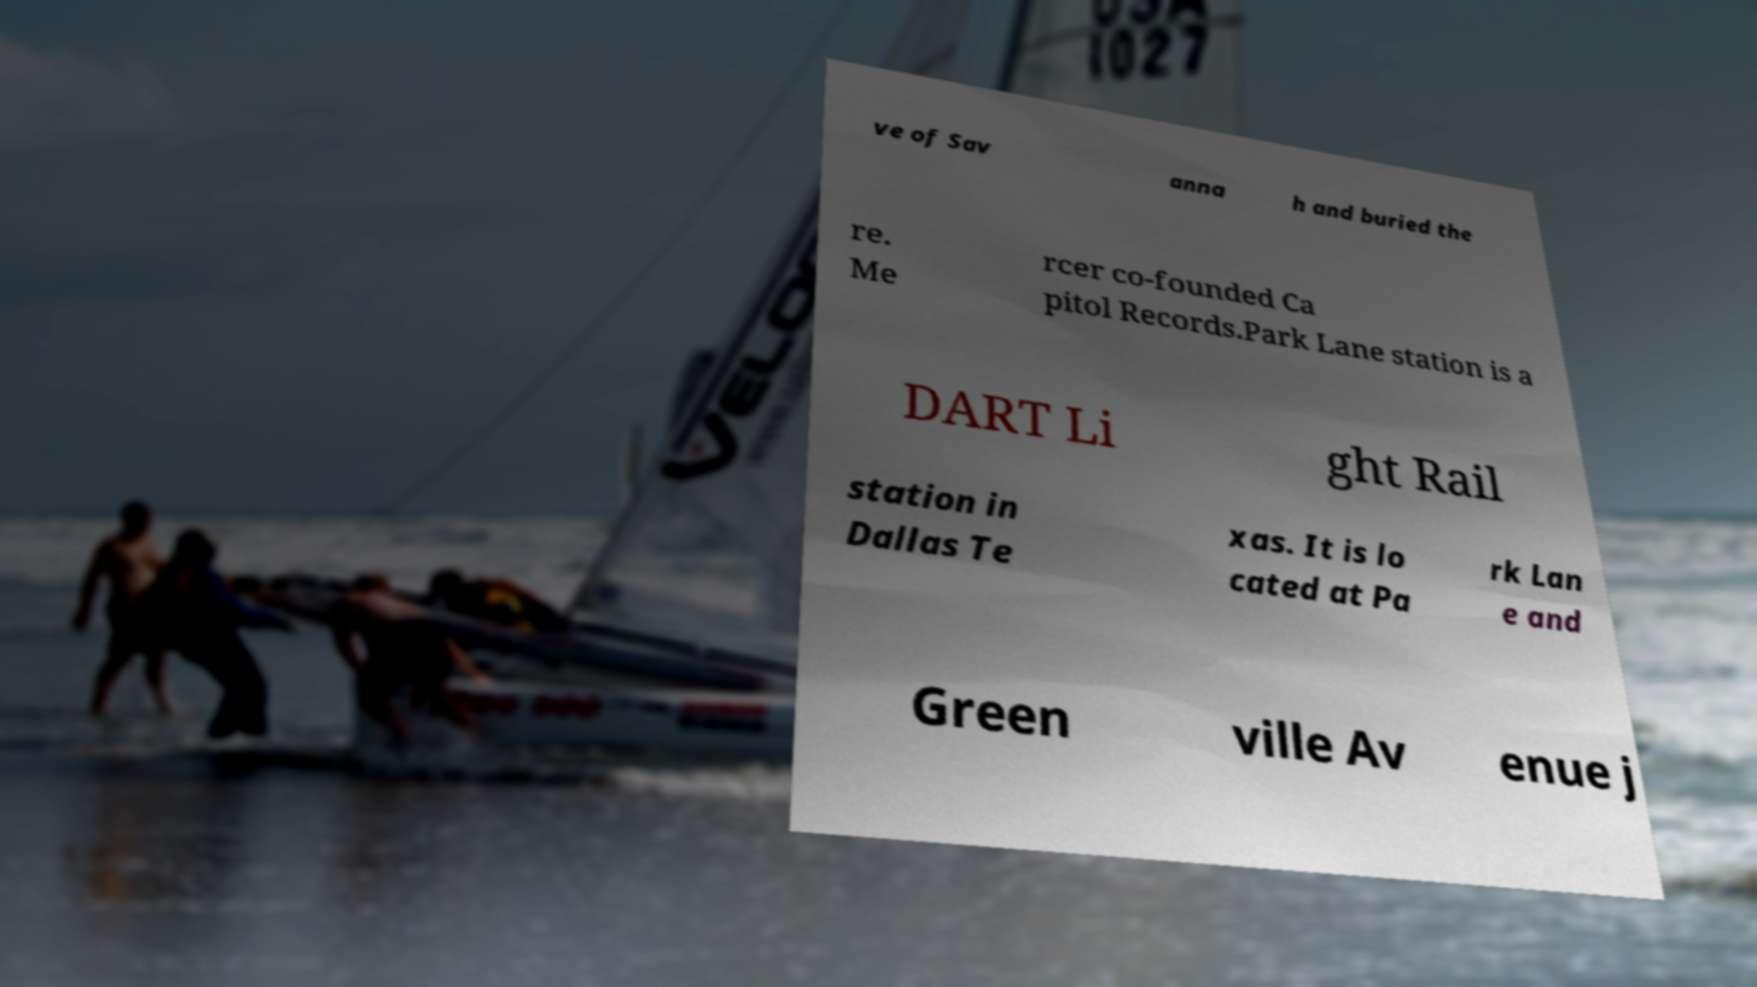Can you read and provide the text displayed in the image?This photo seems to have some interesting text. Can you extract and type it out for me? ve of Sav anna h and buried the re. Me rcer co-founded Ca pitol Records.Park Lane station is a DART Li ght Rail station in Dallas Te xas. It is lo cated at Pa rk Lan e and Green ville Av enue j 